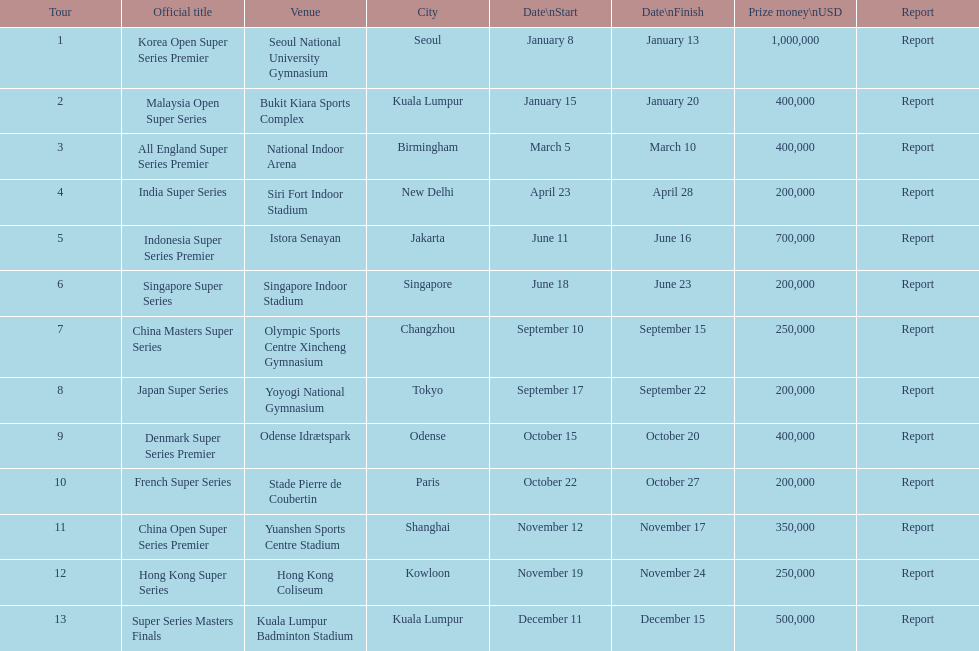How long did the japan super series take? 5 days. 